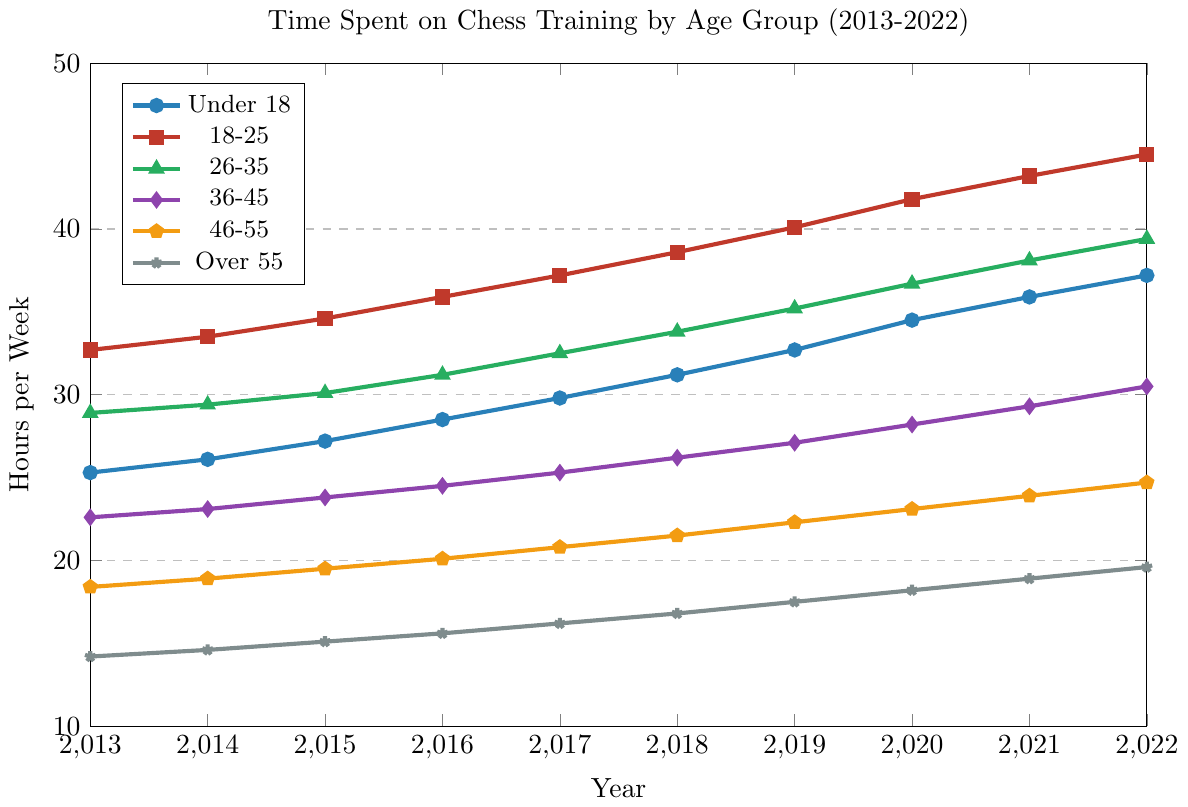What age group has consistently spent the most time on chess training over the decade? By looking at the chart, the age group 18-25 (depicted with red squares) has consistently recorded the highest hours of training from 2013 to 2022.
Answer: 18-25 Which age group had the largest increase in time spent on chess training from 2013 to 2022? To determine the largest increase, calculate the difference between 2022 and 2013 for all age groups and compare. The Under 18 group increased from 25.3 to 37.2 hours, which is 11.9 hours, the highest increase among all groups.
Answer: Under 18 Which age group had the smallest change in hours spent on chess training from 2013 to 2022? By calculating the difference for each group, the Over 55 group increasing from 14.2 to 19.6 hours results in a 5.4-hour increase, the smallest among all groups.
Answer: Over 55 What is the average time spent on chess training in 2022 across all age groups? Summing the hours for 2022 across all age groups and then dividing by the number of age groups (6): (37.2 + 44.5 + 39.4 + 30.5 + 24.7 + 19.6) / 6 = 32.65.
Answer: 32.65 Did any age group decrease their time spent on chess training from 2013 to 2022? Upon inspecting each line for the entire time period from 2013 to 2022, none of the age groups have a decreasing trend. All age groups have an increase in hours spent on training.
Answer: No For which year did the 26-35 age group spend the same amount of time on training as the 36-45 age group? From comparing the values between the two groups year by year, in 2013, 26-35 spent 28.9 hours and 36-45 spent 29.4 hours. No years show the exact same hours, but the closest similarity is in 2015: 26-35 spent 30.1 hours and 36-45 spent 23.8 hours.
Answer: None Among the listed years, which year showed the steepest increase in training hours for the Under 18 age group? By looking closely at the points for Under 18, compare year-to-year changes: the largest jump is from 2019 (32.7) to 2020 (34.5), an increase of 1.8 hours.
Answer: 2020 What was the average annual increase in training hours for the 46-55 age group over the decade? To find the average annual increase, calculate the total increase: 24.7 - 18.4 = 6.3 hours, then divide by the number of years (9): 6.3 / 9 ≈ 0.7.
Answer: 0.7 Which age group had the second highest training hours in 2019? By comparing the values for 2019, 18-25 had 40.1 hours making them the highest, and the second highest was 26-35 with 35.2 hours.
Answer: 26-35 